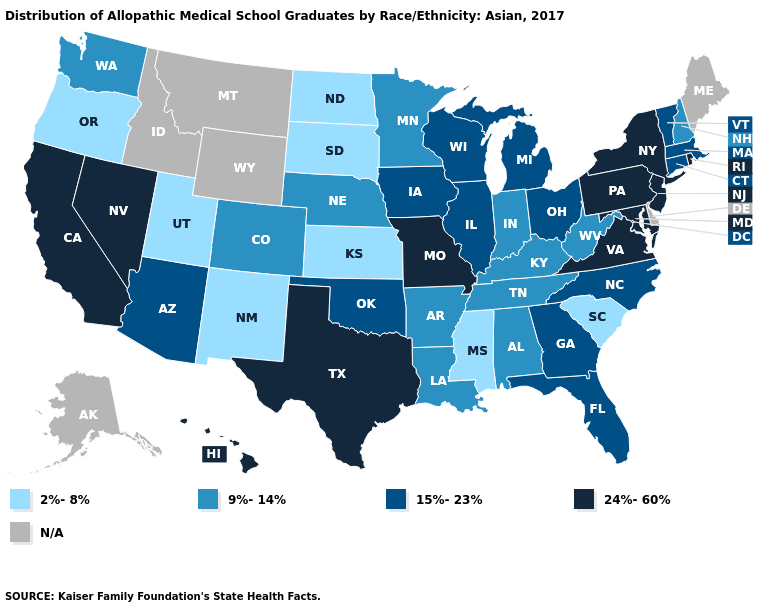Which states hav the highest value in the MidWest?
Quick response, please. Missouri. What is the value of West Virginia?
Give a very brief answer. 9%-14%. Name the states that have a value in the range N/A?
Quick response, please. Alaska, Delaware, Idaho, Maine, Montana, Wyoming. Does Oklahoma have the highest value in the USA?
Answer briefly. No. Does the first symbol in the legend represent the smallest category?
Short answer required. Yes. What is the value of Arkansas?
Concise answer only. 9%-14%. Does the map have missing data?
Quick response, please. Yes. What is the lowest value in the MidWest?
Write a very short answer. 2%-8%. What is the value of Iowa?
Quick response, please. 15%-23%. Name the states that have a value in the range 24%-60%?
Answer briefly. California, Hawaii, Maryland, Missouri, Nevada, New Jersey, New York, Pennsylvania, Rhode Island, Texas, Virginia. What is the value of North Carolina?
Answer briefly. 15%-23%. Which states have the highest value in the USA?
Quick response, please. California, Hawaii, Maryland, Missouri, Nevada, New Jersey, New York, Pennsylvania, Rhode Island, Texas, Virginia. Name the states that have a value in the range N/A?
Short answer required. Alaska, Delaware, Idaho, Maine, Montana, Wyoming. 